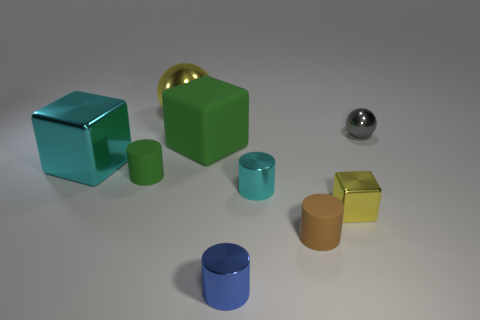Do the materials of the objects in the image have any real-world applications? The materials visible in the image, such as metal and what appears to be plastic or painted wood, have numerous applications in the real world. Metal is used for its durability and reflective qualities in machinery and décor, while the materials of the colored cubes could be used in children's blocks, furniture, or educational tools due to their smooth surfaces and varied colors.  What do the colors of the objects tell you about the possible settings where they could be found? The bright and varied colors of the objects suggest they could be part of a creative or educational setting, such as a classroom, playroom, or design studio. These colors can stimulate visual interest and are often chosen to engage the attention of viewers, learners, or consumers in environments where visual appeal and interaction are important. 